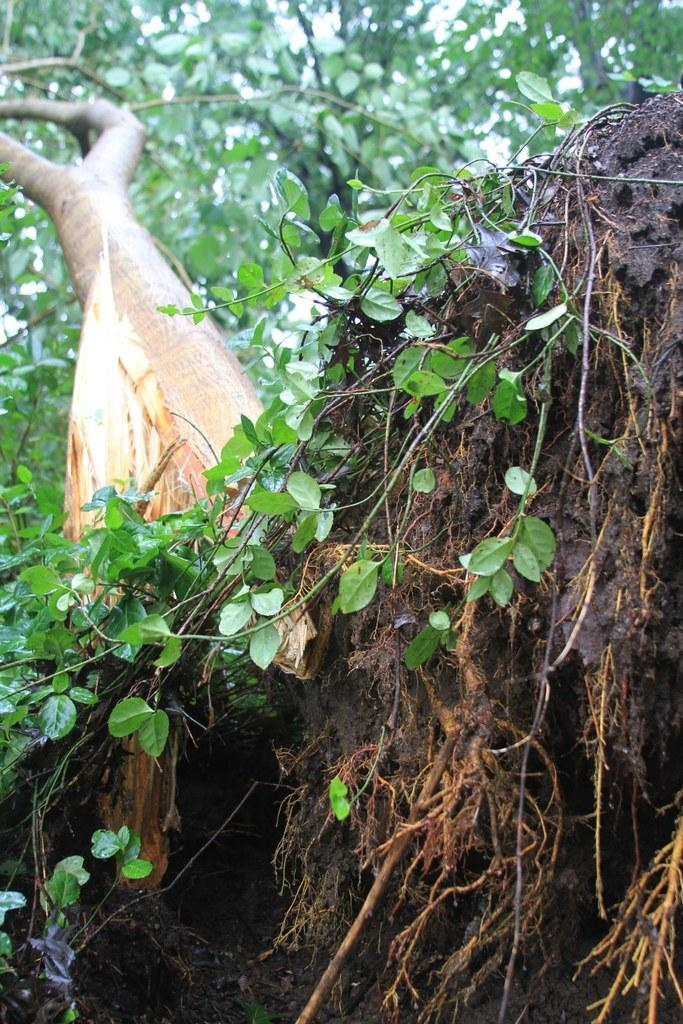What is the main subject of the picture? The main subject of the picture is a tree. Can you describe the tree's structure? The tree has a trunk and roots. What is surrounding the tree? Soil is visible around the tree. What is covering the tree's branches? There are leaves on the tree. Can you see any rabbits hiding among the tree's roots in the image? There are no rabbits present in the image; it only features a tree with a trunk, roots, soil, and leaves. 